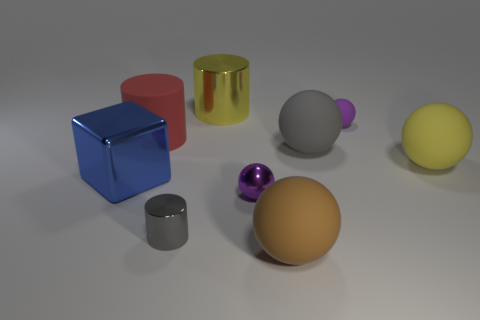Subtract all green cylinders. How many purple balls are left? 2 Subtract all tiny metallic balls. How many balls are left? 4 Subtract all gray spheres. How many spheres are left? 4 Add 1 big cyan metallic cylinders. How many objects exist? 10 Subtract all blocks. How many objects are left? 8 Subtract all green cylinders. Subtract all brown blocks. How many cylinders are left? 3 Subtract all big metal cubes. Subtract all small purple balls. How many objects are left? 6 Add 4 large matte balls. How many large matte balls are left? 7 Add 6 green cubes. How many green cubes exist? 6 Subtract 0 gray blocks. How many objects are left? 9 